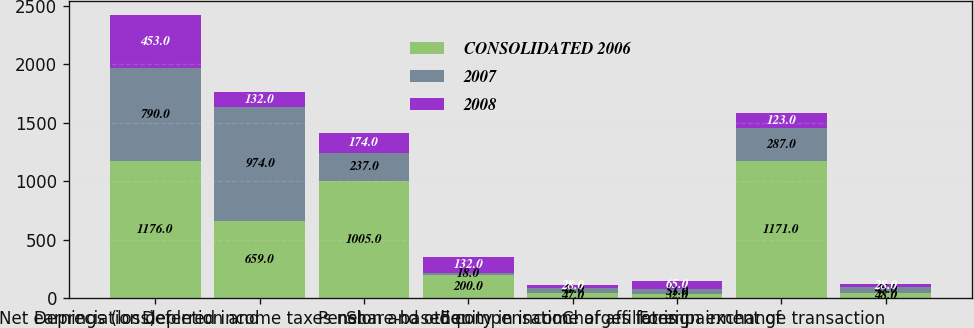<chart> <loc_0><loc_0><loc_500><loc_500><stacked_bar_chart><ecel><fcel>Net earnings (loss)<fcel>Depreciation depletion and<fcel>Deferred income taxes net<fcel>Pension and other<fcel>Share-based compensation<fcel>Equity in income of affiliates<fcel>Charges for impairment of<fcel>Foreign exchange transaction<nl><fcel>CONSOLIDATED 2006<fcel>1176<fcel>659<fcel>1005<fcel>200<fcel>47<fcel>32<fcel>1171<fcel>48<nl><fcel>2007<fcel>790<fcel>974<fcel>237<fcel>18<fcel>41<fcel>51<fcel>287<fcel>45<nl><fcel>2008<fcel>453<fcel>132<fcel>174<fcel>132<fcel>28<fcel>65<fcel>123<fcel>28<nl></chart> 